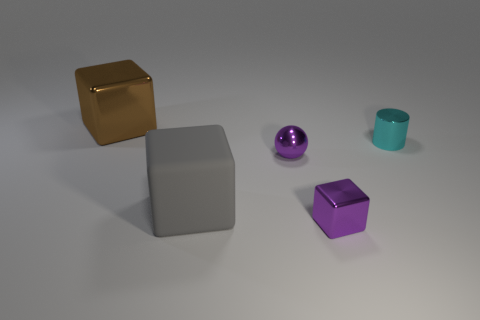Add 5 green metal cylinders. How many objects exist? 10 Subtract all blocks. How many objects are left? 2 Subtract 0 cyan cubes. How many objects are left? 5 Subtract all big cyan rubber cylinders. Subtract all purple metal objects. How many objects are left? 3 Add 5 small cyan metal cylinders. How many small cyan metal cylinders are left? 6 Add 2 large gray metal blocks. How many large gray metal blocks exist? 2 